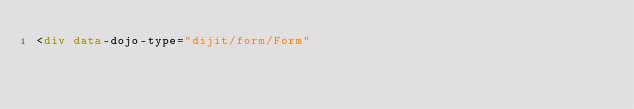<code> <loc_0><loc_0><loc_500><loc_500><_HTML_><div data-dojo-type="dijit/form/Form"</code> 